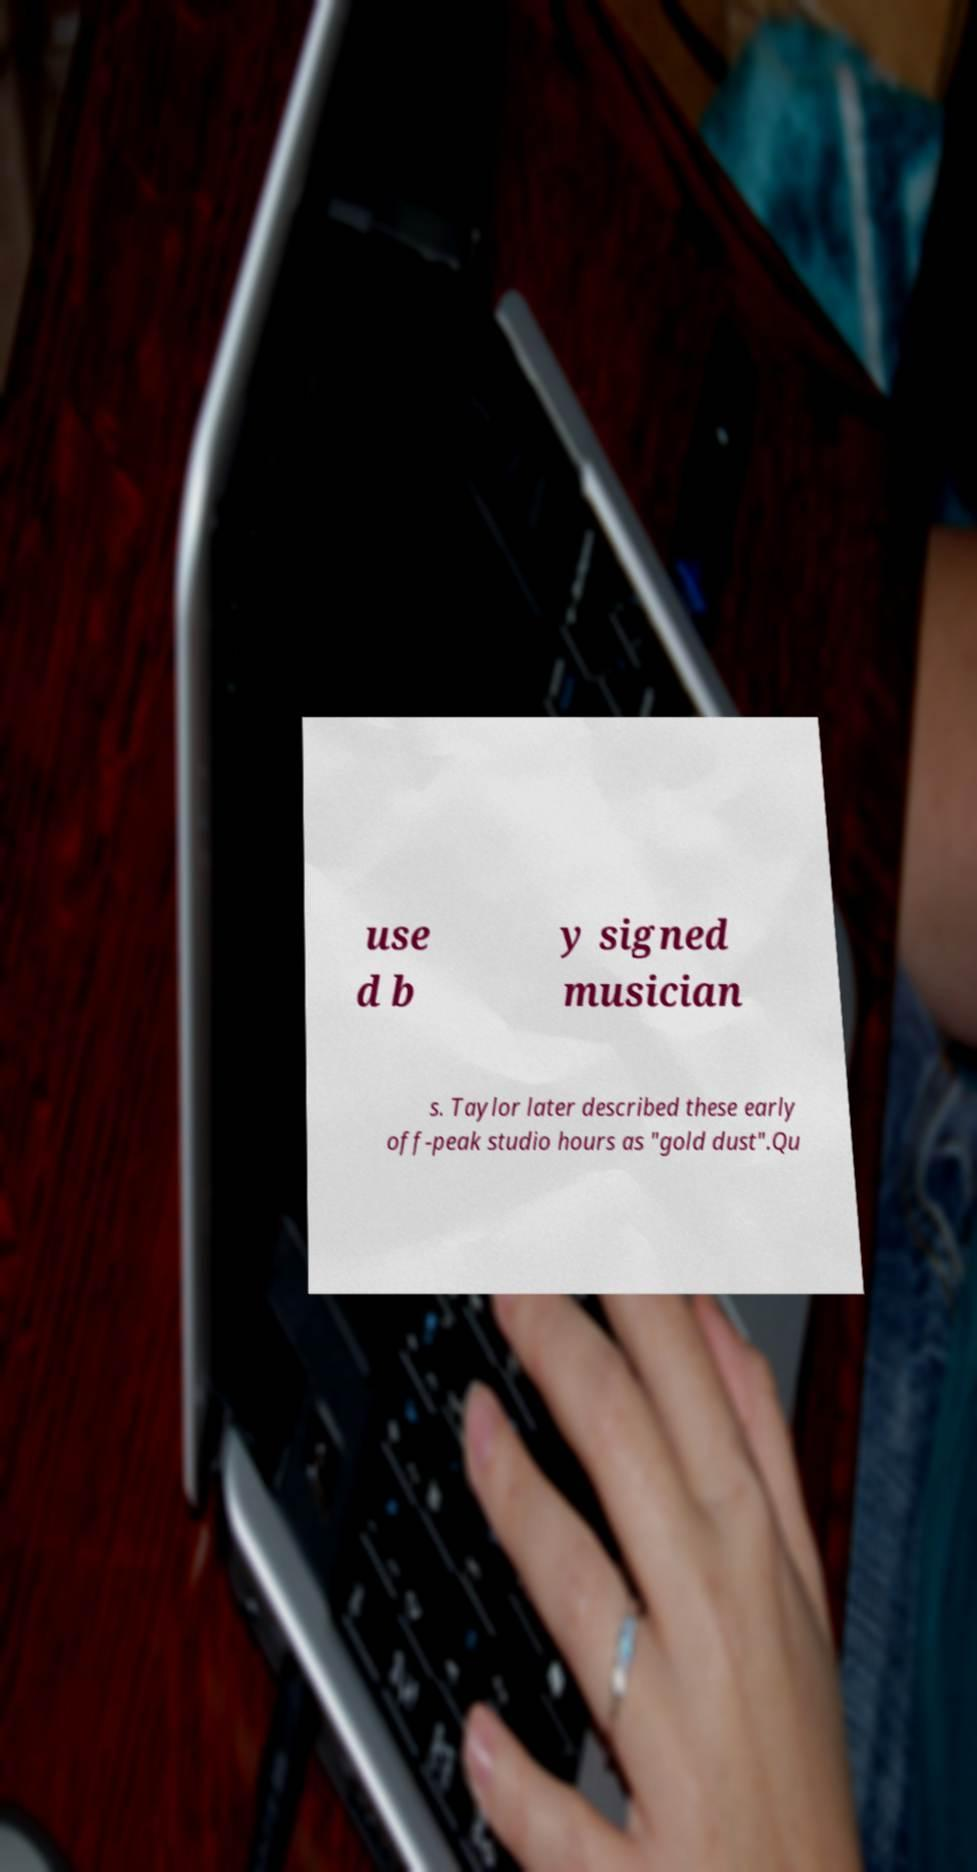Can you read and provide the text displayed in the image?This photo seems to have some interesting text. Can you extract and type it out for me? use d b y signed musician s. Taylor later described these early off-peak studio hours as "gold dust".Qu 